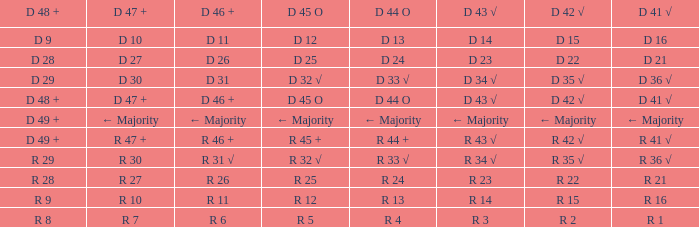What is the importance of d 47 + when the importance of d 44 o is r 24? R 27. 